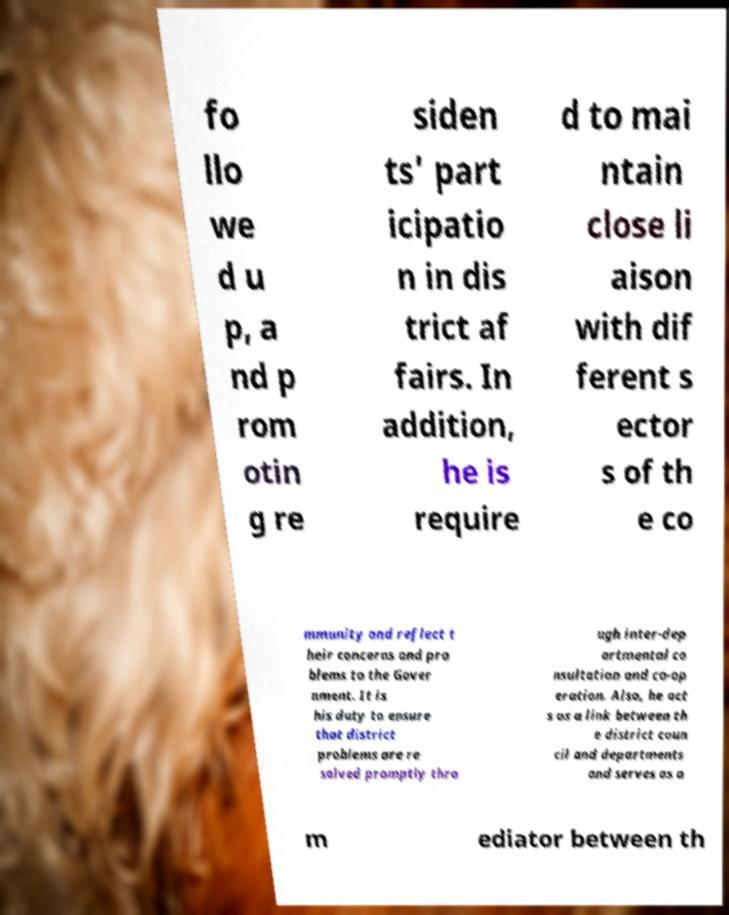Please read and relay the text visible in this image. What does it say? fo llo we d u p, a nd p rom otin g re siden ts' part icipatio n in dis trict af fairs. In addition, he is require d to mai ntain close li aison with dif ferent s ector s of th e co mmunity and reflect t heir concerns and pro blems to the Gover nment. It is his duty to ensure that district problems are re solved promptly thro ugh inter-dep artmental co nsultation and co-op eration. Also, he act s as a link between th e district coun cil and departments and serves as a m ediator between th 